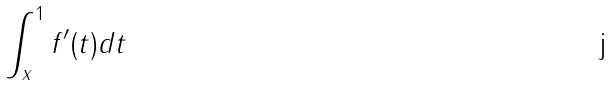<formula> <loc_0><loc_0><loc_500><loc_500>\int _ { x } ^ { 1 } f ^ { \prime } ( t ) d t</formula> 